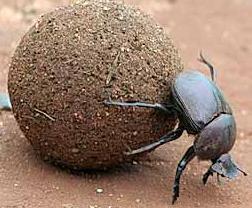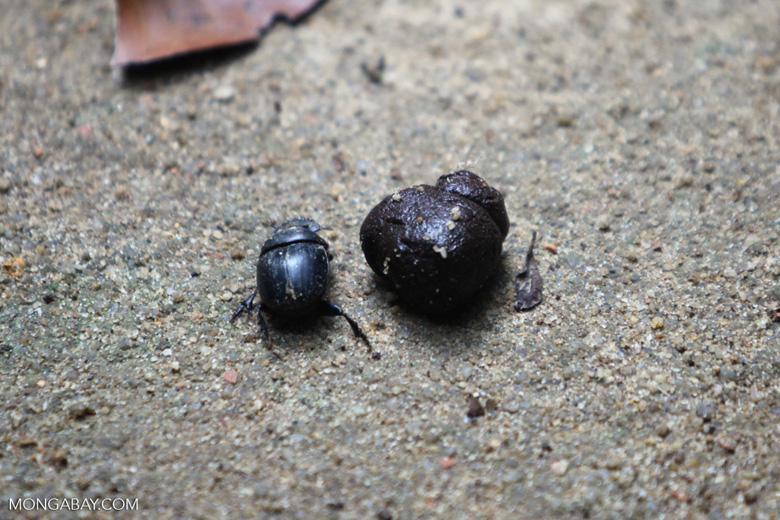The first image is the image on the left, the second image is the image on the right. Examine the images to the left and right. Is the description "The beetle in the image on the left is on the right of the ball of dirt." accurate? Answer yes or no. Yes. The first image is the image on the left, the second image is the image on the right. For the images displayed, is the sentence "An image shows a beetle with its hind legs on a dung ball and its head facing the ground." factually correct? Answer yes or no. Yes. 